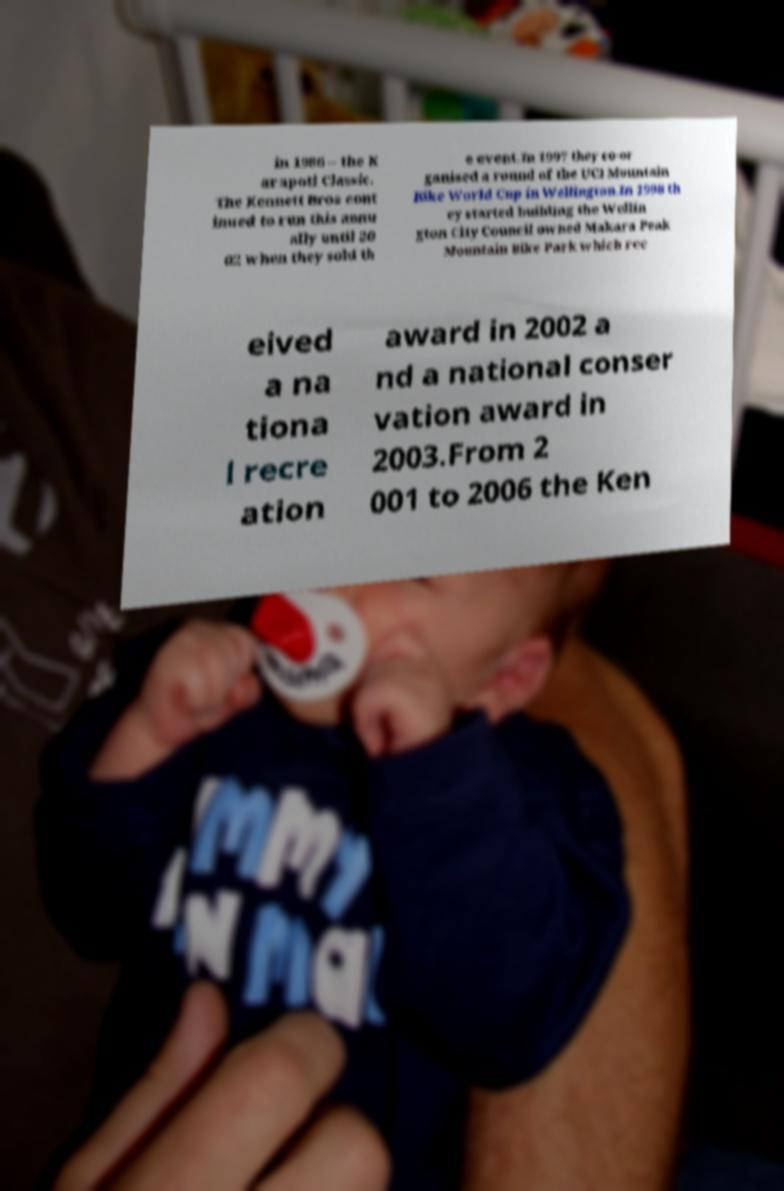I need the written content from this picture converted into text. Can you do that? in 1986 – the K arapoti Classic. The Kennett Bros cont inued to run this annu ally until 20 02 when they sold th e event.In 1997 they co-or ganised a round of the UCI Mountain Bike World Cup in Wellington.In 1998 th ey started building the Wellin gton City Council owned Makara Peak Mountain Bike Park which rec eived a na tiona l recre ation award in 2002 a nd a national conser vation award in 2003.From 2 001 to 2006 the Ken 